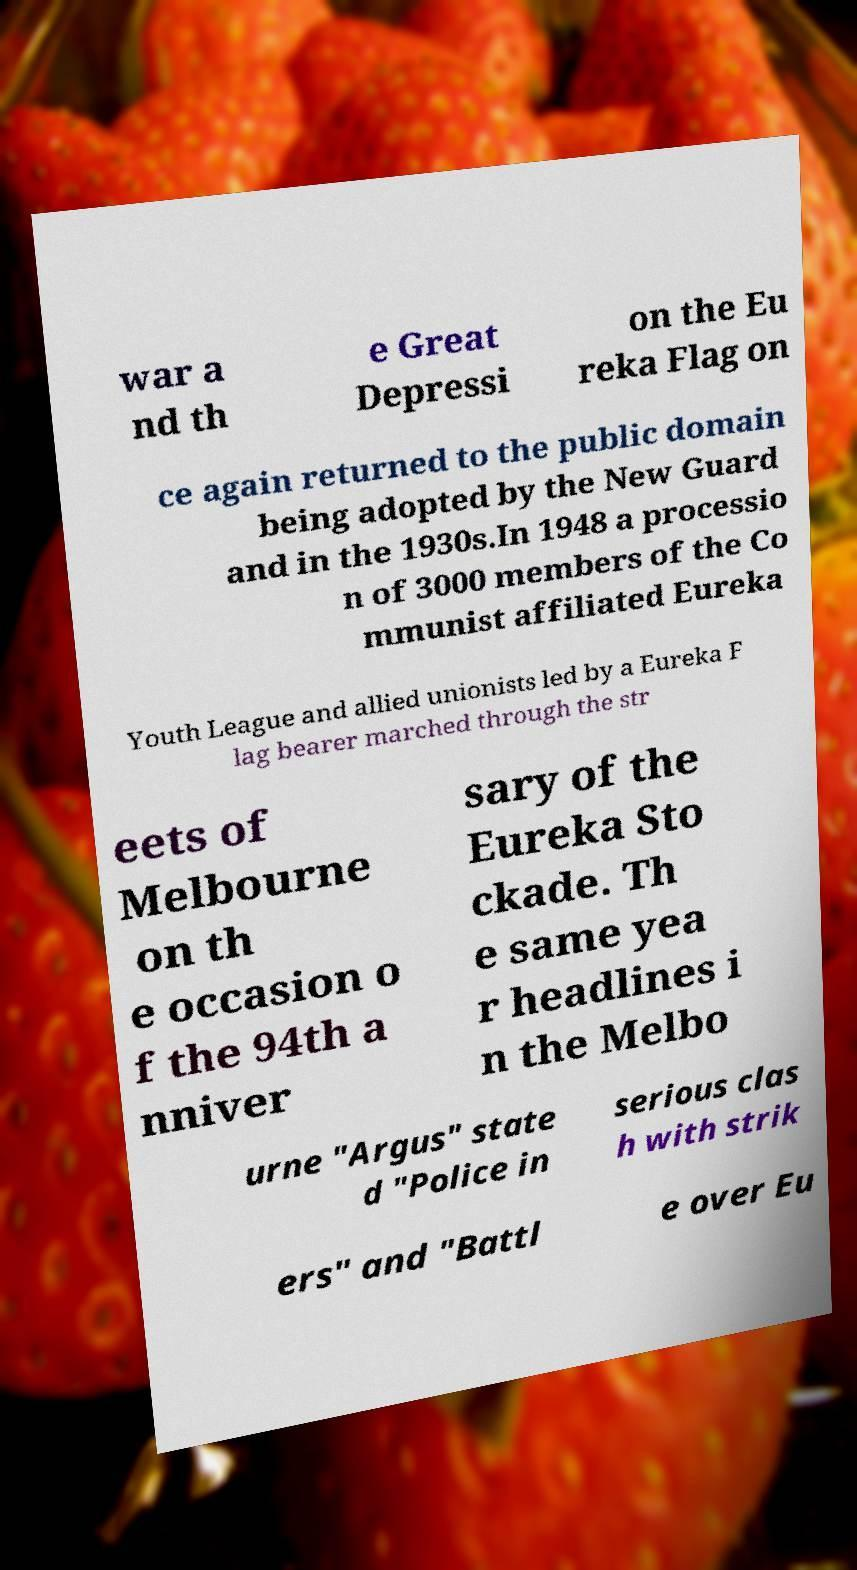I need the written content from this picture converted into text. Can you do that? war a nd th e Great Depressi on the Eu reka Flag on ce again returned to the public domain being adopted by the New Guard and in the 1930s.In 1948 a processio n of 3000 members of the Co mmunist affiliated Eureka Youth League and allied unionists led by a Eureka F lag bearer marched through the str eets of Melbourne on th e occasion o f the 94th a nniver sary of the Eureka Sto ckade. Th e same yea r headlines i n the Melbo urne "Argus" state d "Police in serious clas h with strik ers" and "Battl e over Eu 